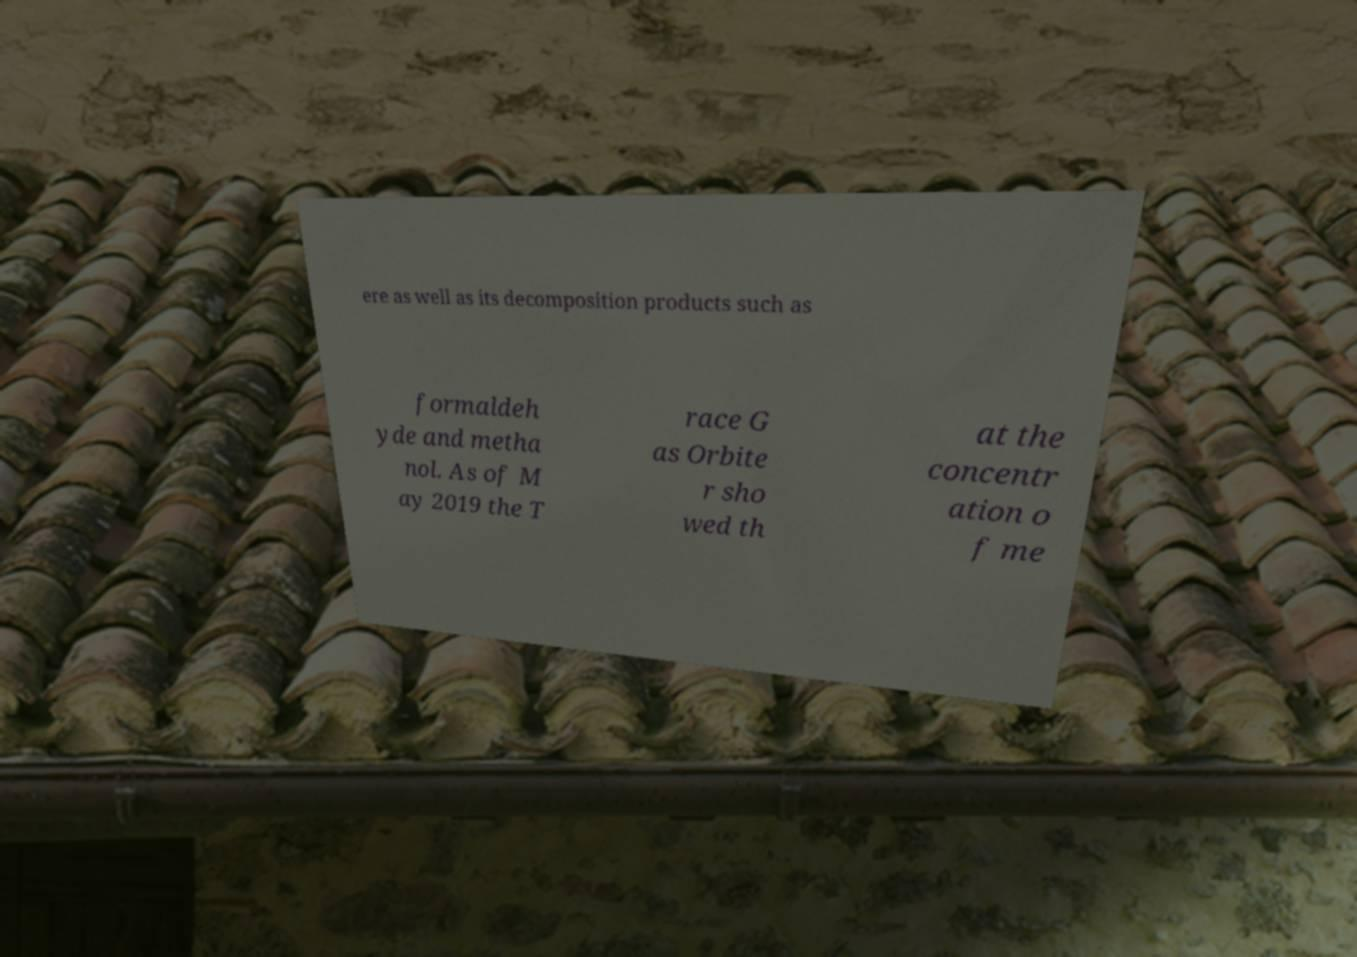Please identify and transcribe the text found in this image. ere as well as its decomposition products such as formaldeh yde and metha nol. As of M ay 2019 the T race G as Orbite r sho wed th at the concentr ation o f me 